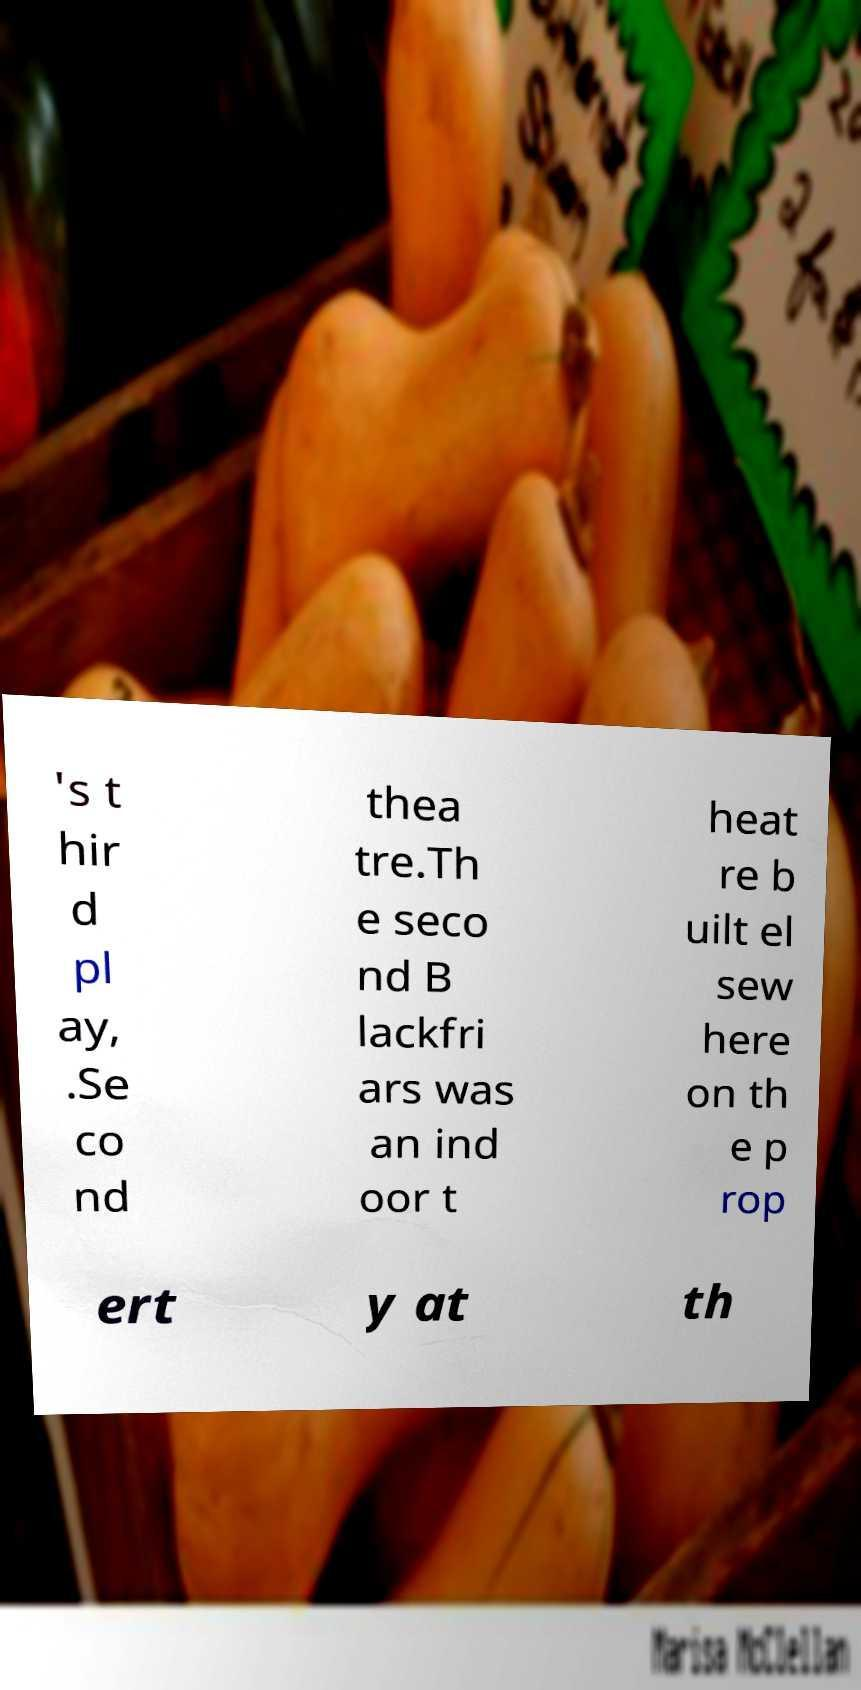Can you read and provide the text displayed in the image?This photo seems to have some interesting text. Can you extract and type it out for me? 's t hir d pl ay, .Se co nd thea tre.Th e seco nd B lackfri ars was an ind oor t heat re b uilt el sew here on th e p rop ert y at th 